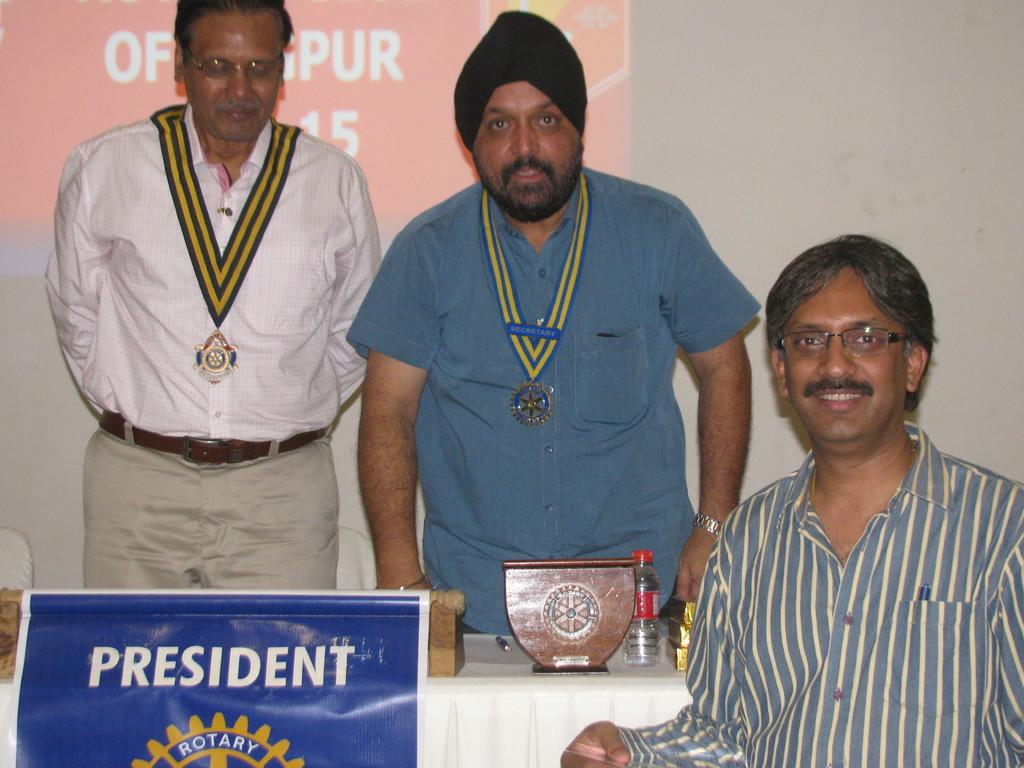<image>
Summarize the visual content of the image. the sign that says President in front of some men 